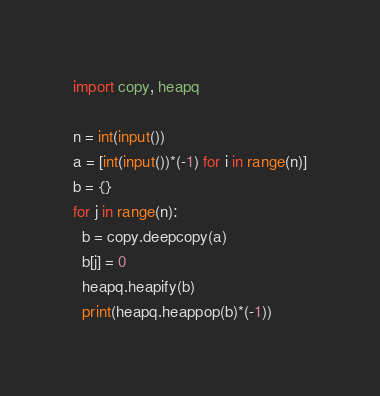<code> <loc_0><loc_0><loc_500><loc_500><_Python_>import copy, heapq

n = int(input())
a = [int(input())*(-1) for i in range(n)]
b = {}
for j in range(n):
  b = copy.deepcopy(a)
  b[j] = 0
  heapq.heapify(b)
  print(heapq.heappop(b)*(-1))</code> 